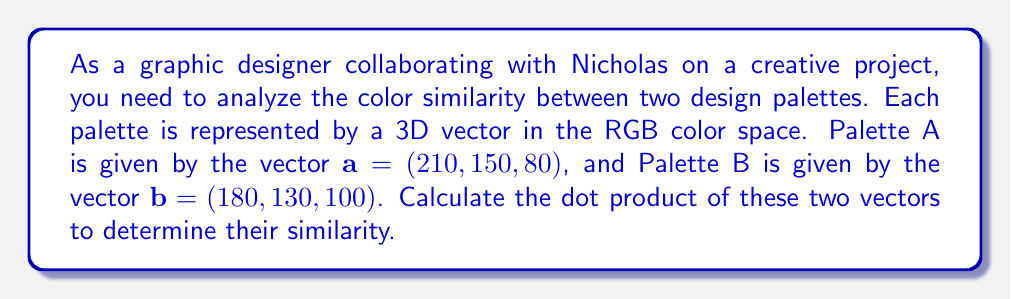Can you answer this question? To analyze the color similarity between the two design palettes, we'll compute the dot product of their corresponding vectors. The dot product provides a measure of how similar two vectors are in terms of their direction and magnitude.

Given:
- Palette A: $\mathbf{a} = (210, 150, 80)$
- Palette B: $\mathbf{b} = (180, 130, 100)$

The dot product of two vectors $\mathbf{a} = (a_1, a_2, a_3)$ and $\mathbf{b} = (b_1, b_2, b_3)$ is defined as:

$$\mathbf{a} \cdot \mathbf{b} = a_1b_1 + a_2b_2 + a_3b_3$$

Let's calculate each component:

1. $a_1b_1 = 210 \times 180 = 37,800$
2. $a_2b_2 = 150 \times 130 = 19,500$
3. $a_3b_3 = 80 \times 100 = 8,000$

Now, we sum these components:

$$\mathbf{a} \cdot \mathbf{b} = 37,800 + 19,500 + 8,000 = 65,300$$

The resulting dot product is 65,300. This value indicates the degree of similarity between the two color palettes. A higher dot product generally suggests more similarity, while a lower dot product indicates less similarity. However, to get a normalized measure of similarity, you might want to consider using the cosine similarity, which involves dividing the dot product by the magnitudes of the vectors.
Answer: The dot product of the two color palette vectors is 65,300. 